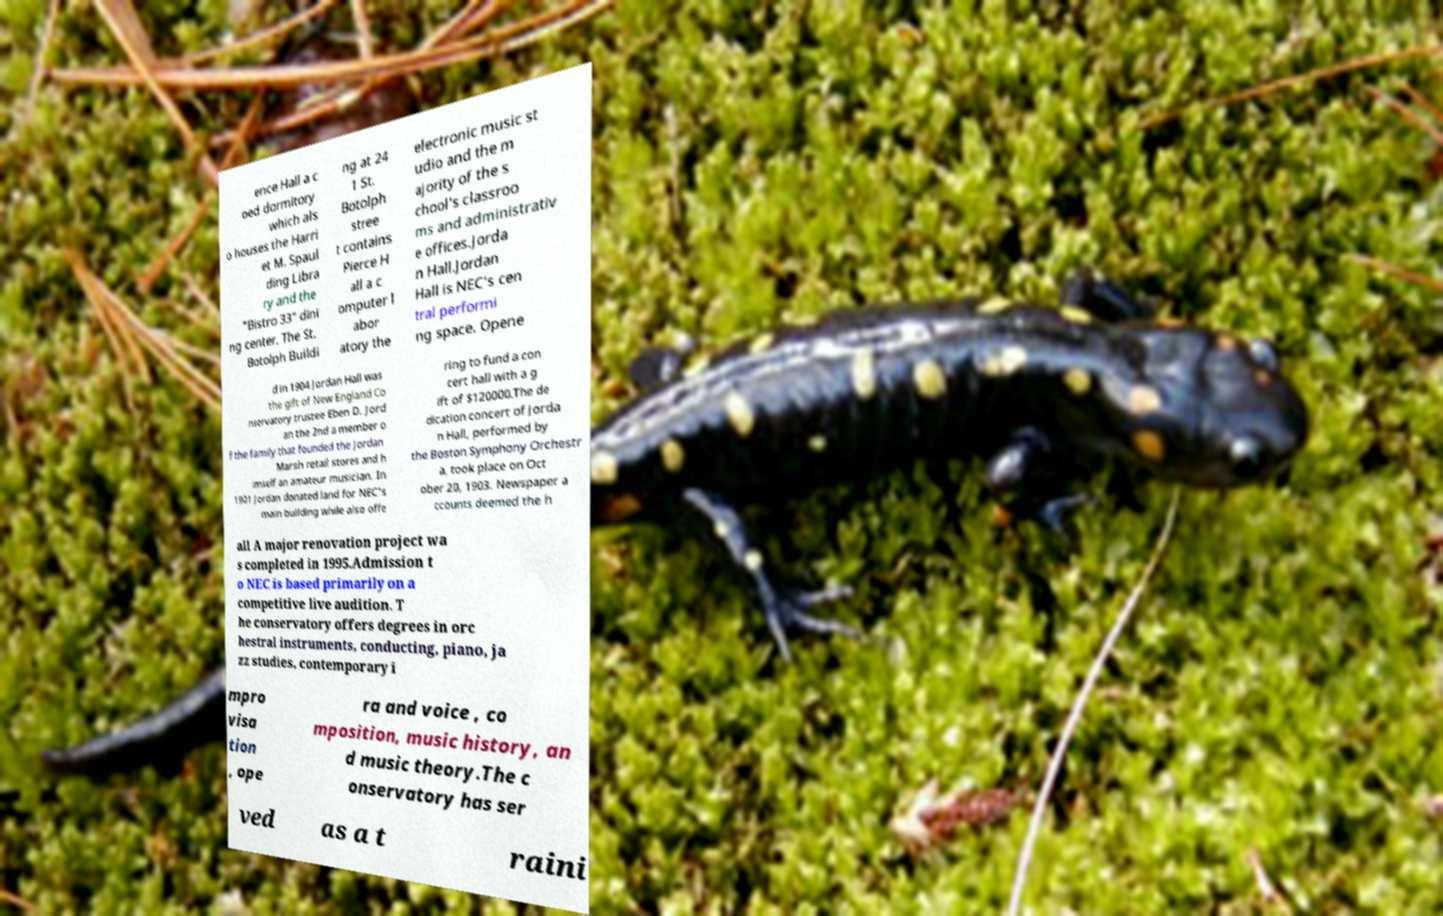There's text embedded in this image that I need extracted. Can you transcribe it verbatim? ence Hall a c oed dormitory which als o houses the Harri et M. Spaul ding Libra ry and the "Bistro 33" dini ng center. The St. Botolph Buildi ng at 24 1 St. Botolph stree t contains Pierce H all a c omputer l abor atory the electronic music st udio and the m ajority of the s chool's classroo ms and administrativ e offices.Jorda n Hall.Jordan Hall is NEC's cen tral performi ng space. Opene d in 1904 Jordan Hall was the gift of New England Co nservatory trustee Eben D. Jord an the 2nd a member o f the family that founded the Jordan Marsh retail stores and h imself an amateur musician. In 1901 Jordan donated land for NEC's main building while also offe ring to fund a con cert hall with a g ift of $120000.The de dication concert of Jorda n Hall, performed by the Boston Symphony Orchestr a, took place on Oct ober 20, 1903. Newspaper a ccounts deemed the h all A major renovation project wa s completed in 1995.Admission t o NEC is based primarily on a competitive live audition. T he conservatory offers degrees in orc hestral instruments, conducting, piano, ja zz studies, contemporary i mpro visa tion , ope ra and voice , co mposition, music history, an d music theory.The c onservatory has ser ved as a t raini 